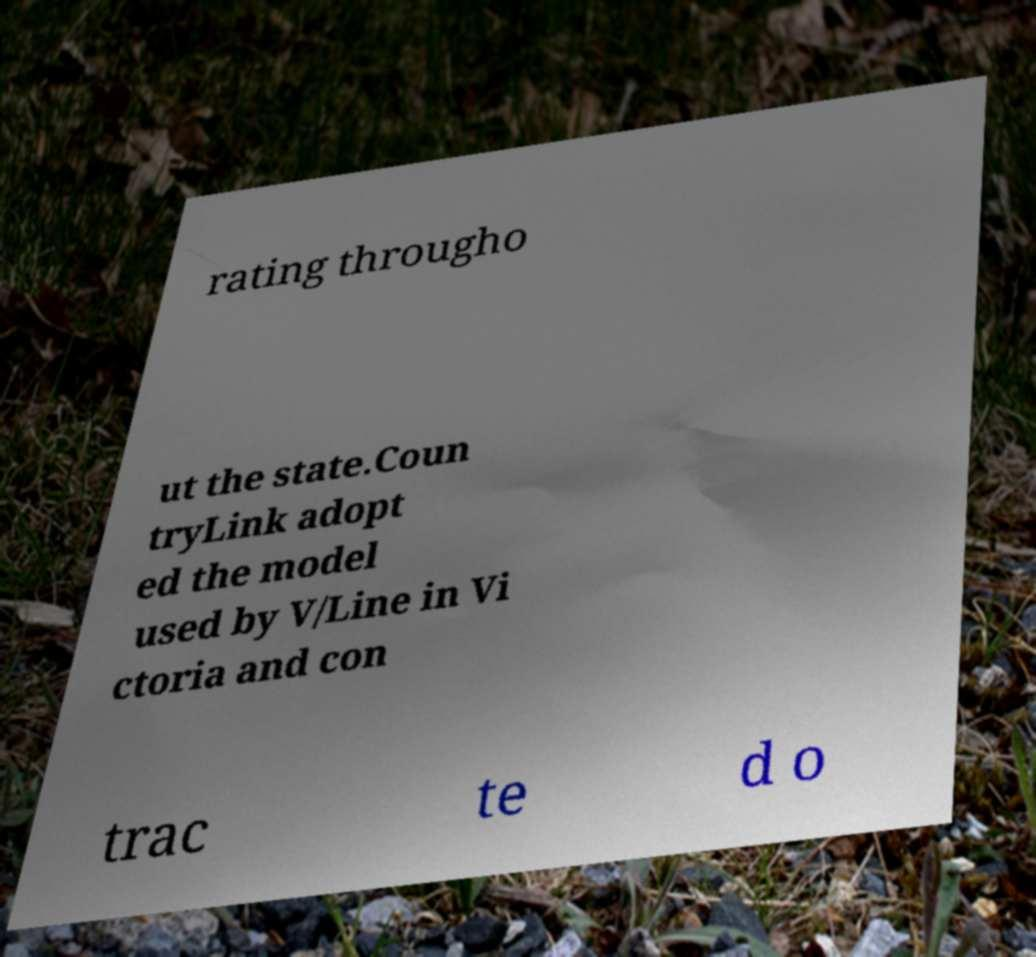Could you assist in decoding the text presented in this image and type it out clearly? rating througho ut the state.Coun tryLink adopt ed the model used by V/Line in Vi ctoria and con trac te d o 